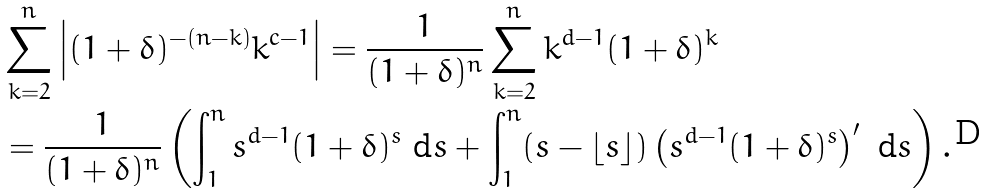<formula> <loc_0><loc_0><loc_500><loc_500>& \sum _ { k = 2 } ^ { n } \left | ( 1 + \delta ) ^ { - ( n - k ) } k ^ { c - 1 } \right | = \frac { 1 } { ( 1 + \delta ) ^ { n } } \sum _ { k = 2 } ^ { n } k ^ { d - 1 } ( 1 + \delta ) ^ { k } \\ & = \frac { 1 } { ( 1 + \delta ) ^ { n } } \left ( \int _ { 1 } ^ { n } s ^ { d - 1 } ( 1 + \delta ) ^ { s } \ \text {d} s + \int _ { 1 } ^ { n } ( s - \lfloor s \rfloor ) \left ( s ^ { d - 1 } ( 1 + \delta ) ^ { s } \right ) ^ { \prime } \ \text {d} s \right ) .</formula> 